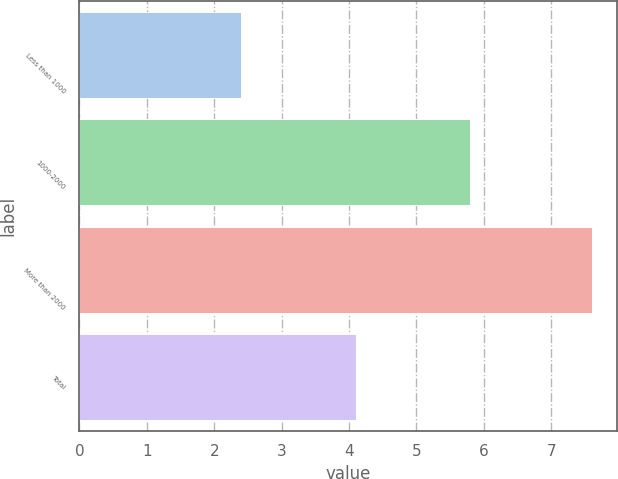<chart> <loc_0><loc_0><loc_500><loc_500><bar_chart><fcel>Less than 1000<fcel>1000-2000<fcel>More than 2000<fcel>Total<nl><fcel>2.4<fcel>5.8<fcel>7.6<fcel>4.1<nl></chart> 